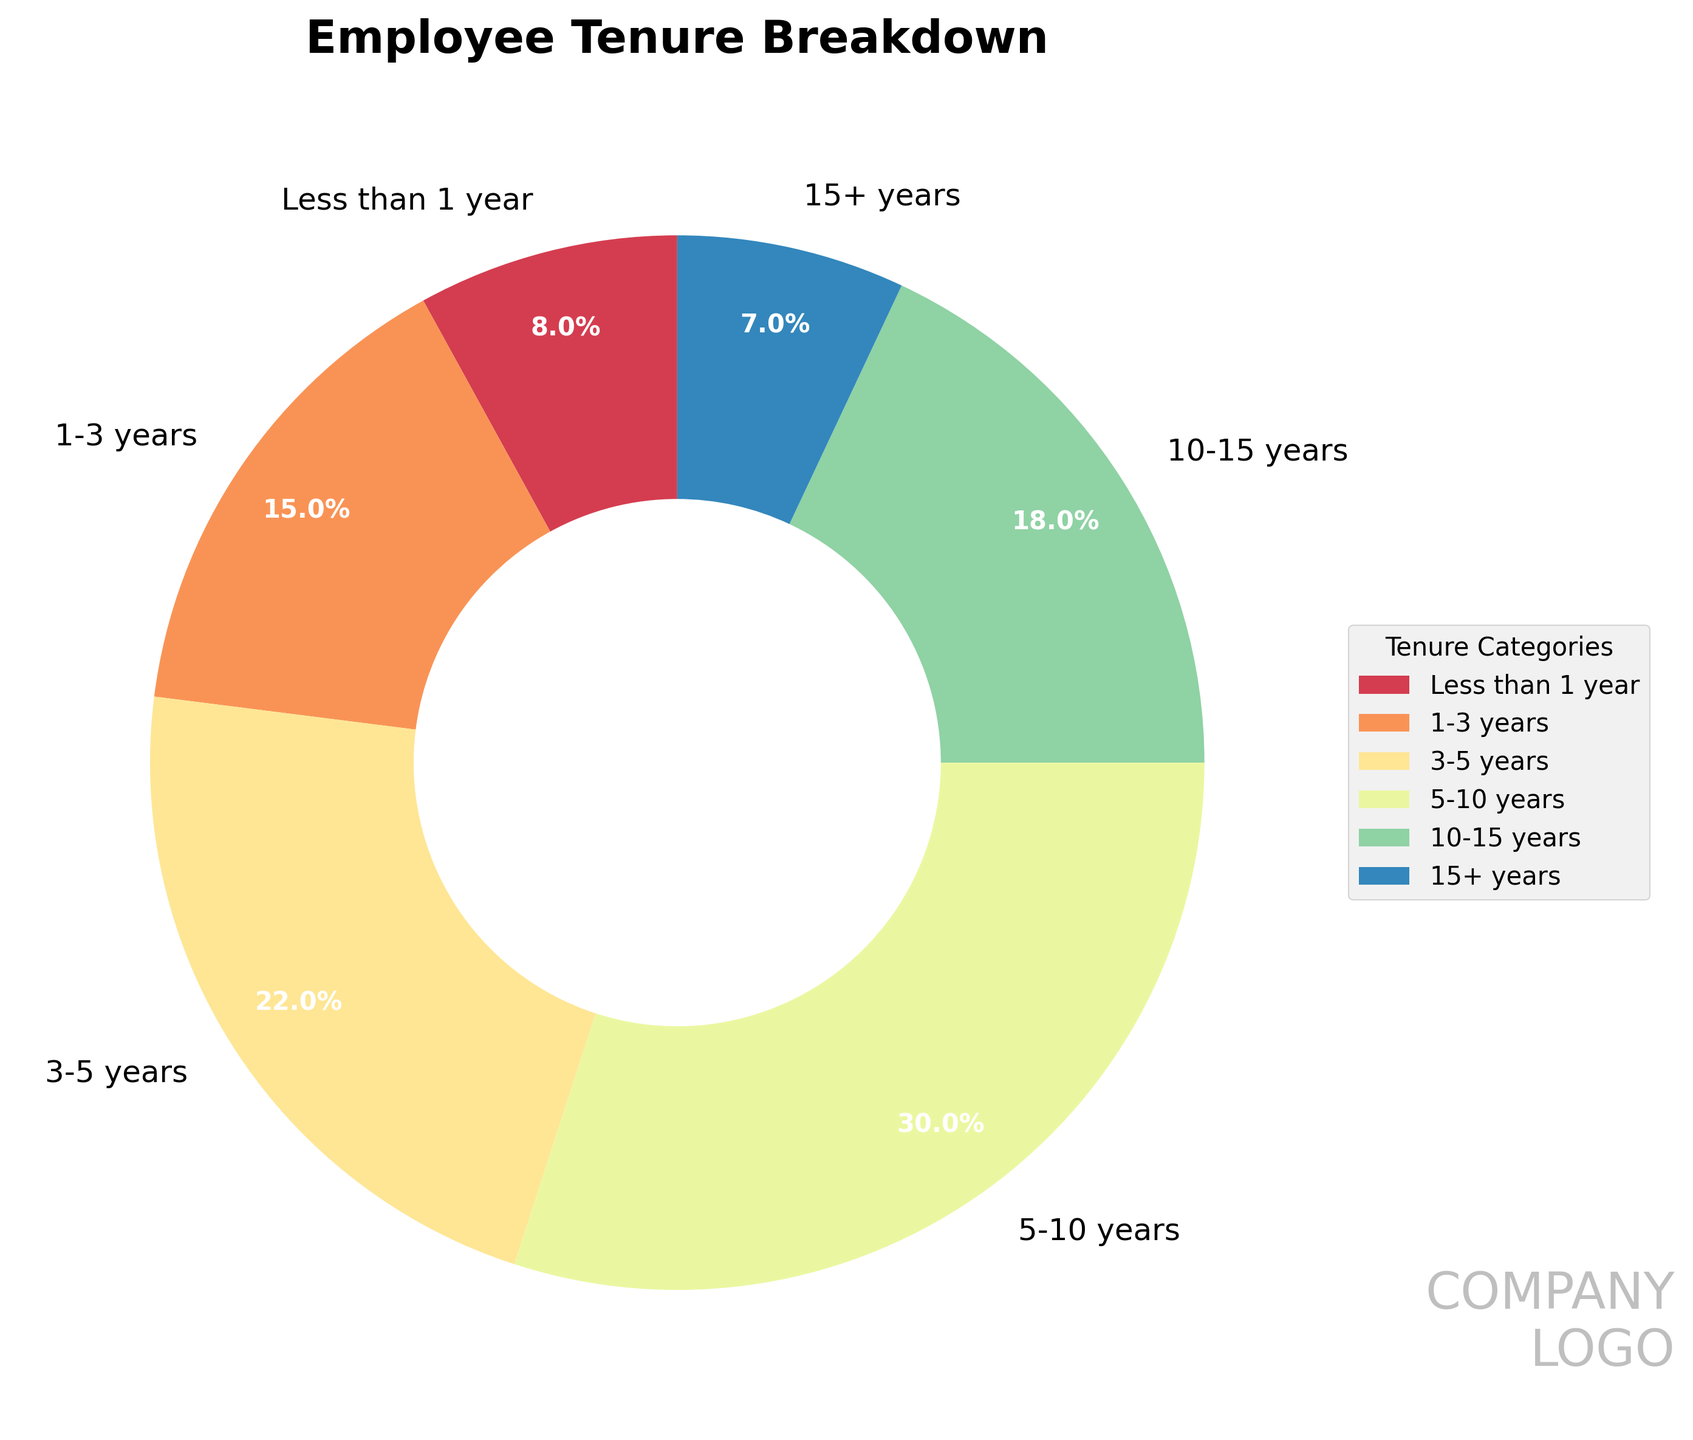What's the percentage of employees with less than 3 years of tenure combined? To find the percentage of employees with less than 3 years of tenure, add the percentages of the categories 'Less than 1 year' and '1-3 years': 8% and 15%. Therefore, 8 + 15 = 23%.
Answer: 23% Which tenure category has the majority of employees? The category with the highest percentage indicates the majority. Here, the category '5-10 years' has the highest percentage of 30%, making it the tenure category with the majority of employees.
Answer: 5-10 years Are there more employees with 10+ years of tenure or less than 1 year? Summing up the categories '10-15 years' (18%) and '15+ years' (7%) gives a total of 25% for employees with over 10 years of tenure. Comparing this to the 'Less than 1 year' category which has 8%, it shows there are more employees with 10+ years of tenure.
Answer: 10+ years What is the difference between the percentage of employees with 5-10 years of tenure and those with 15+ years? Subtract the percentage of the '15+ years' category (7%) from the '5-10 years' category (30%): 30 - 7 = 23%.
Answer: 23% Which tenure categories are closest in percentage to each other? By looking at the percentages, the categories '10-15 years' (18%) and '3-5 years' (22%) are closest to each other with a difference of just 4%.
Answer: 10-15 years and 3-5 years What is the total percentage of employees with 5 or more years of tenure? Add the percentages of the categories '5-10 years' (30%), '10-15 years' (18%), and '15+ years' (7%): 30 + 18 + 7 = 55%.
Answer: 55% Is the percentage of employees with 5-10 years greater than the combined percentage of employees with less than 1 year and 15+ years? The combined percentage for 'Less than 1 year' and '15+ years' is 8% + 7% = 15%. Since 30% (5-10 years) is greater than 15%, the statement is true.
Answer: Yes What color is used to represent the '3-5 years' tenure category on the chart? The '3-5 years' category is represented by a color within the color range. Visually, it is often necessary to refer to the chart legend to identify the exact color. Check this detail in the pie chart's legend.
Answer: Varies based on chart What's the percentage difference between the employees with 1-3 years and 3-5 years of tenure? Subtract the percentage of the '1-3 years' category (15%) from the '3-5 years' category (22%): 22 - 15 = 7%.
Answer: 7% How many tenure categories have a lower percentage than '10-15 years'? The '10-15 years' category has 18%, and the categories with lower percentages are 'Less than 1 year' (8%), '1-3 years' (15%), and '15+ years' (7%), making a total of 3 categories.
Answer: 3 